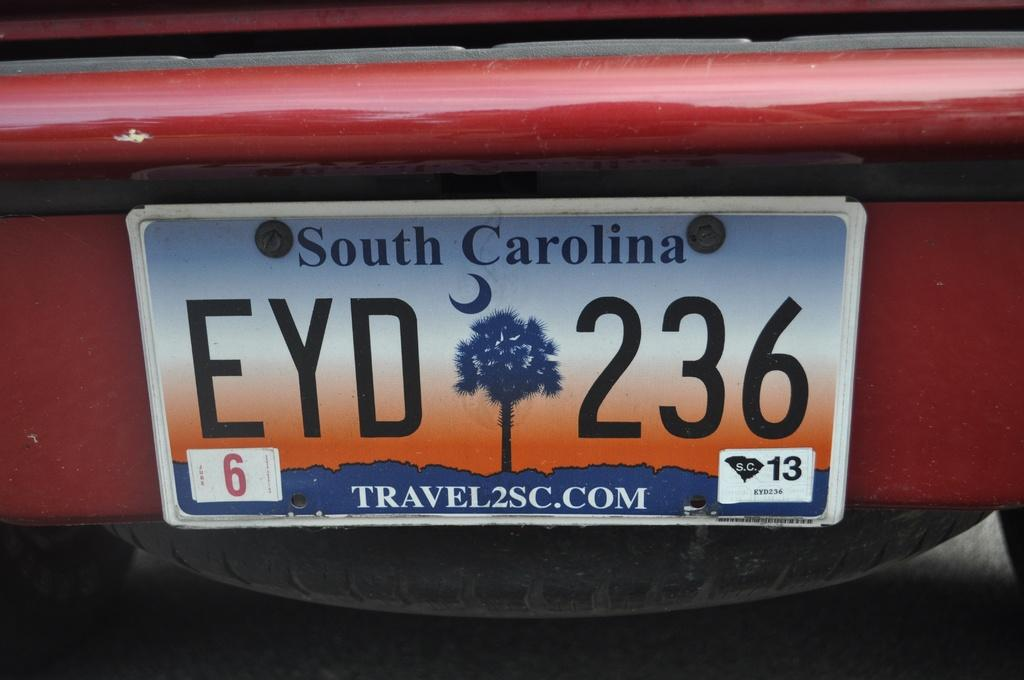<image>
Relay a brief, clear account of the picture shown. License Plate that says EYD 236, 6 Travel2SC.COM 13. 